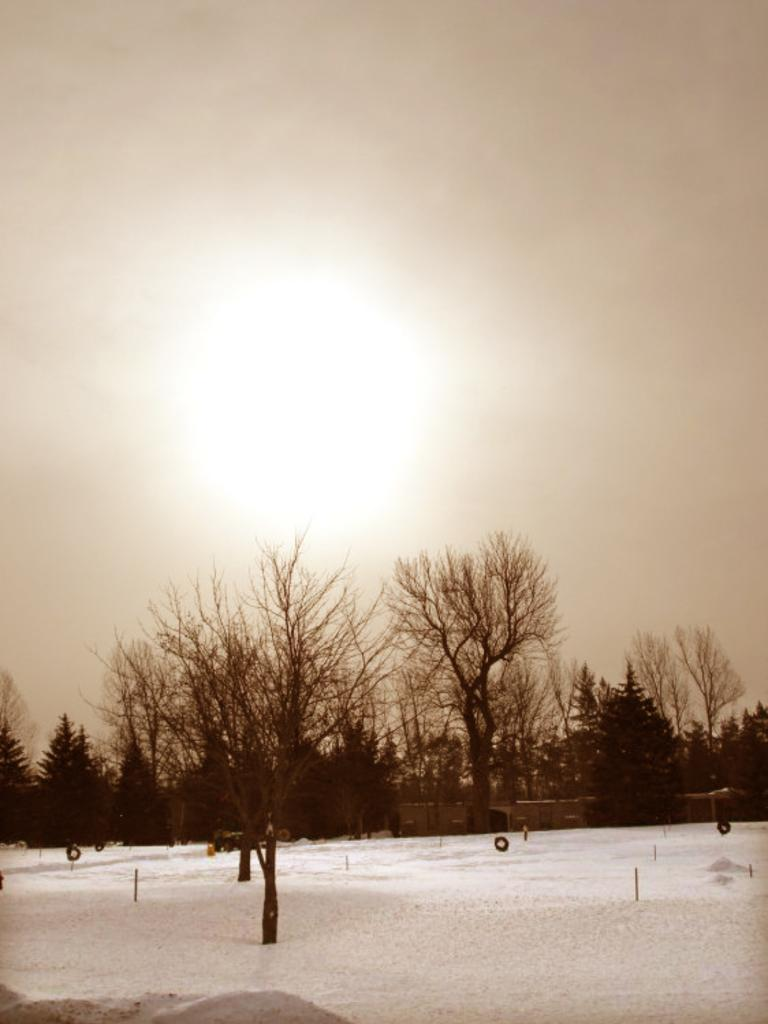What is covering the ground in the image? There is snow on the ground. What type of natural elements can be seen in the image? Trees are visible in the image. What man-made structures are present in the image? Poles and houses are visible in the image. What else can be seen in the image besides the snow, trees, poles, and houses? Objects are present in the image. What is visible in the sky in the background of the image? The sun is observable in the sky in the background. How does the basin help the snow melt faster in the image? There is no basin present in the image, so it cannot help the snow melt faster. What trick is being performed by the snow in the image? There is no trick being performed by the snow in the image; it is simply covering the ground. 